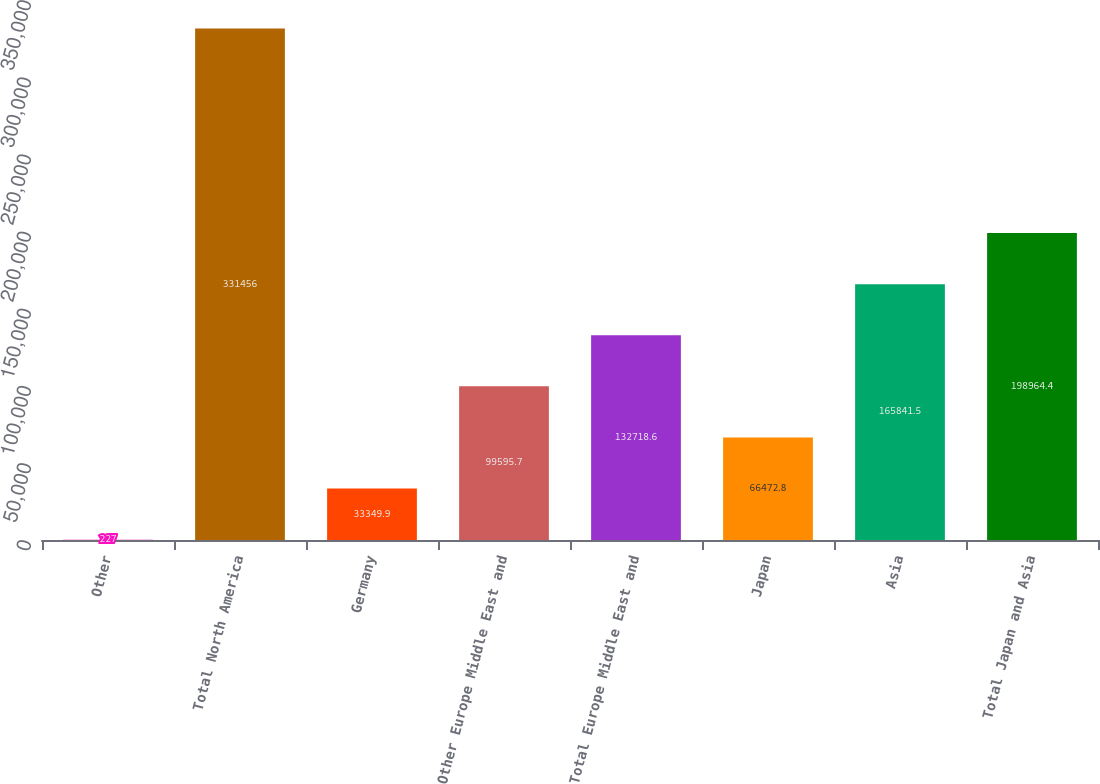Convert chart. <chart><loc_0><loc_0><loc_500><loc_500><bar_chart><fcel>Other<fcel>Total North America<fcel>Germany<fcel>Other Europe Middle East and<fcel>Total Europe Middle East and<fcel>Japan<fcel>Asia<fcel>Total Japan and Asia<nl><fcel>227<fcel>331456<fcel>33349.9<fcel>99595.7<fcel>132719<fcel>66472.8<fcel>165842<fcel>198964<nl></chart> 